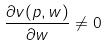<formula> <loc_0><loc_0><loc_500><loc_500>\frac { \partial v ( p , w ) } { \partial w } \ne 0</formula> 